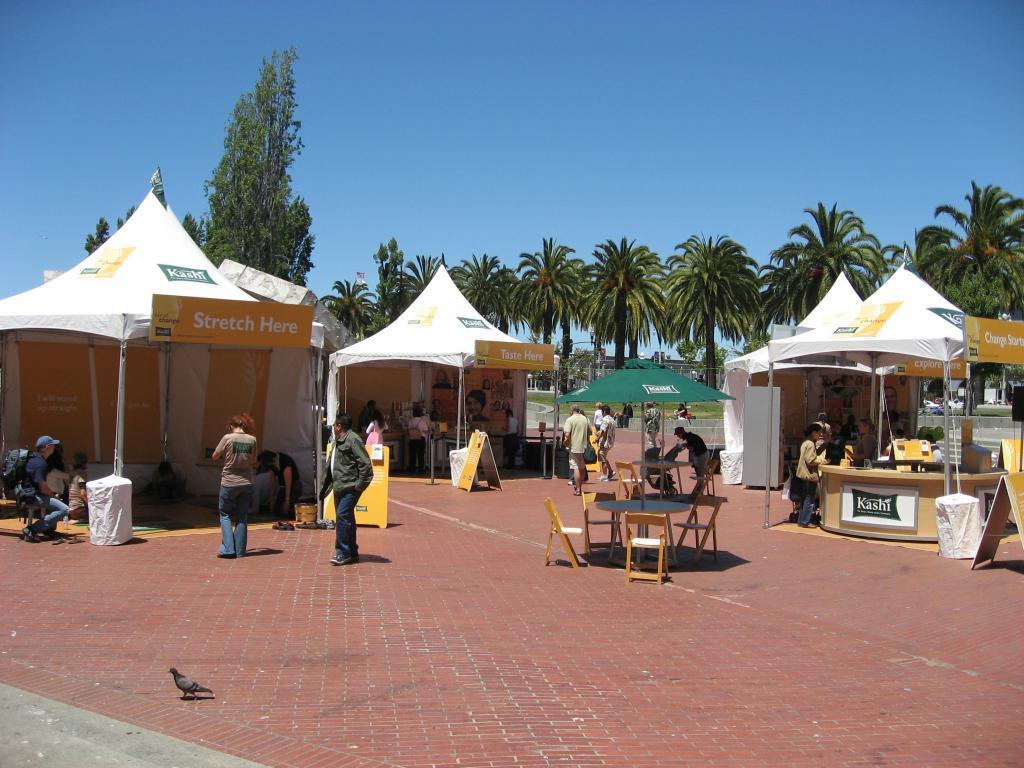Please provide a concise description of this image. In this picture we can see tables, chairs, name boards, tents, poles, trees, banners, grass, pigeon and a group of people on the ground and some objects and in the background we can see the sky. 